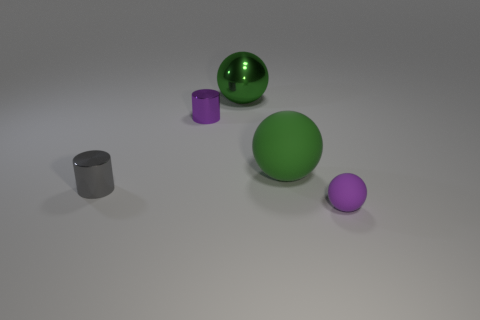Add 3 rubber balls. How many objects exist? 8 Subtract all balls. How many objects are left? 2 Subtract 0 cyan cubes. How many objects are left? 5 Subtract all green metallic balls. Subtract all cylinders. How many objects are left? 2 Add 5 tiny gray shiny objects. How many tiny gray shiny objects are left? 6 Add 4 tiny gray cylinders. How many tiny gray cylinders exist? 5 